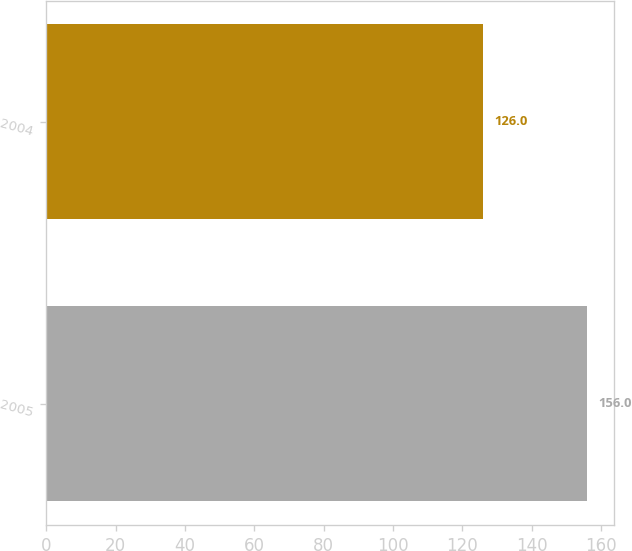<chart> <loc_0><loc_0><loc_500><loc_500><bar_chart><fcel>2005<fcel>2004<nl><fcel>156<fcel>126<nl></chart> 